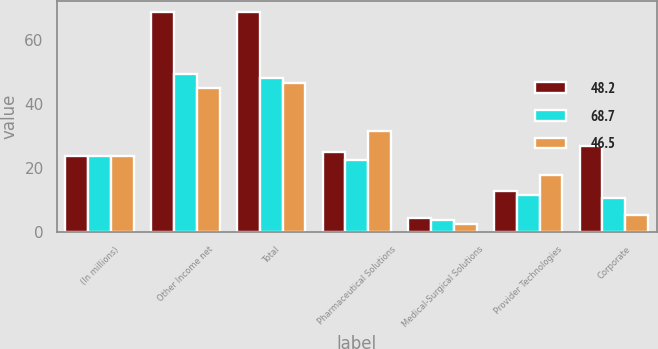<chart> <loc_0><loc_0><loc_500><loc_500><stacked_bar_chart><ecel><fcel>(In millions)<fcel>Other Income net<fcel>Total<fcel>Pharmaceutical Solutions<fcel>Medical-Surgical Solutions<fcel>Provider Technologies<fcel>Corporate<nl><fcel>48.2<fcel>23.7<fcel>68.7<fcel>68.7<fcel>24.9<fcel>4.3<fcel>12.7<fcel>26.8<nl><fcel>68.7<fcel>23.7<fcel>49.4<fcel>48.2<fcel>22.5<fcel>3.7<fcel>11.5<fcel>10.5<nl><fcel>46.5<fcel>23.7<fcel>45.1<fcel>46.5<fcel>31.6<fcel>2.3<fcel>17.9<fcel>5.3<nl></chart> 